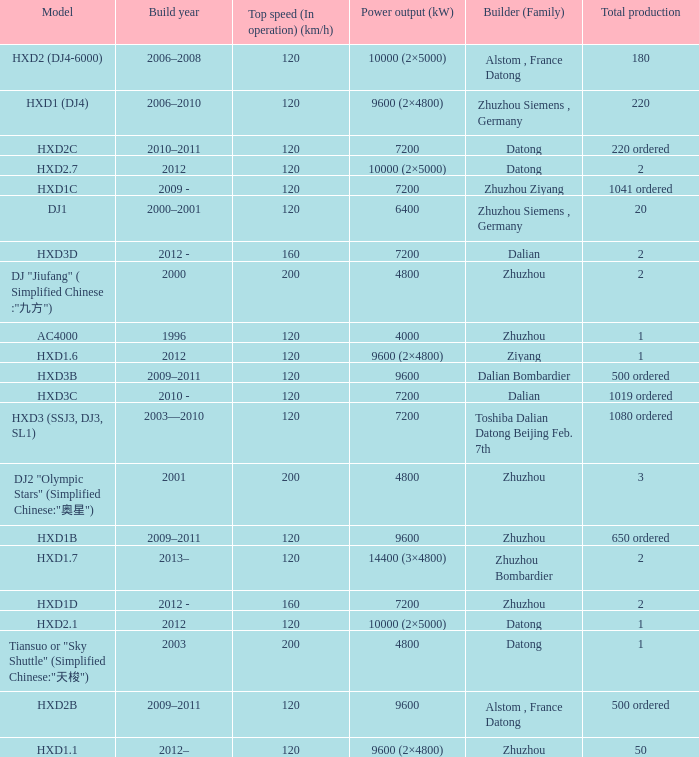What is the power output (kw) of builder zhuzhou, model hxd1d, with a total production of 2? 7200.0. 